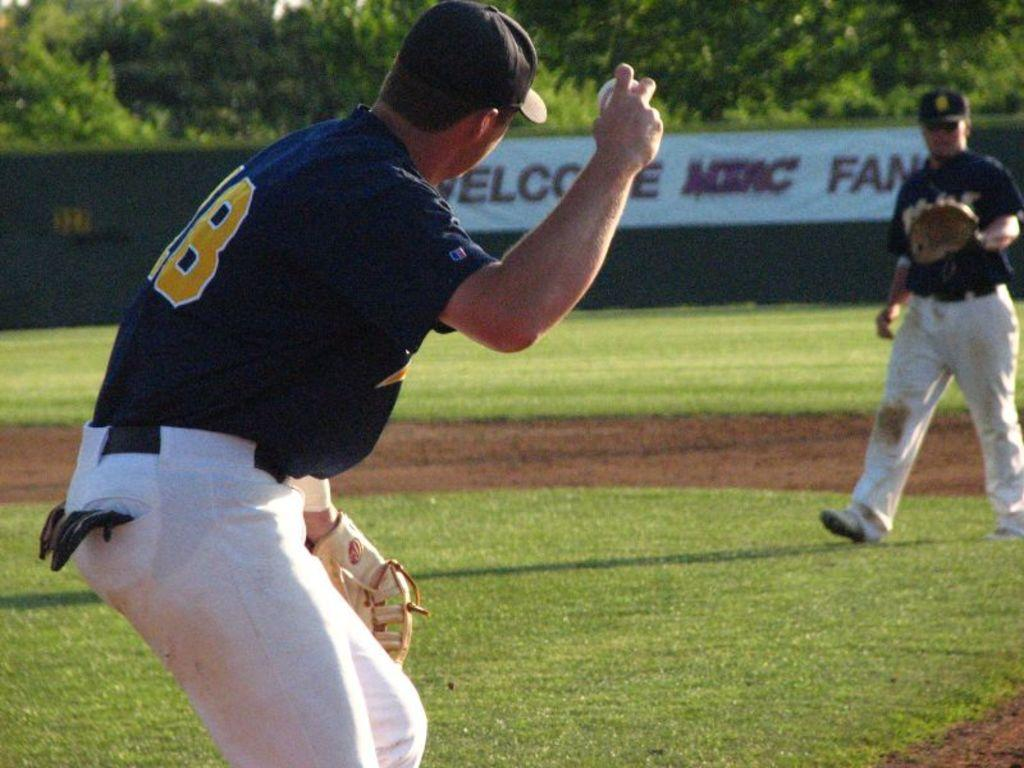<image>
Share a concise interpretation of the image provided. The person in the 18 jersey is getting ready to throw the ball to the other player 